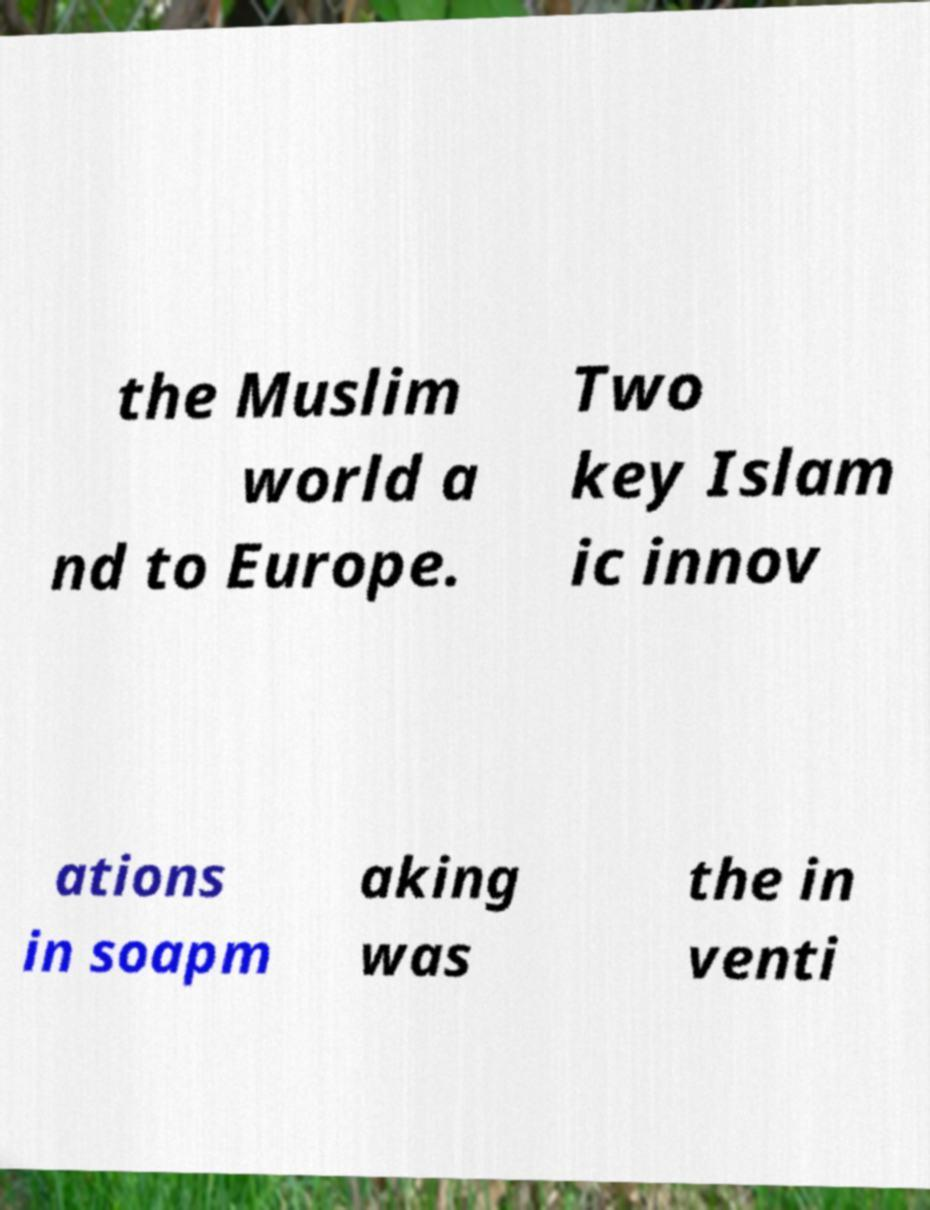Please read and relay the text visible in this image. What does it say? the Muslim world a nd to Europe. Two key Islam ic innov ations in soapm aking was the in venti 